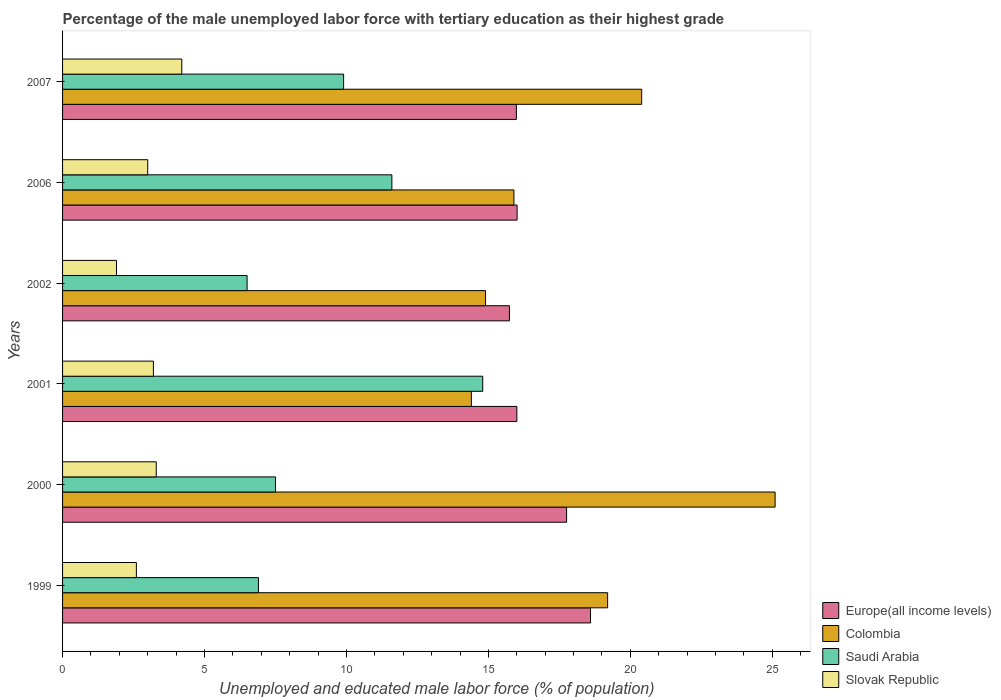How many different coloured bars are there?
Your answer should be compact. 4. How many groups of bars are there?
Offer a terse response. 6. How many bars are there on the 4th tick from the bottom?
Provide a short and direct response. 4. What is the label of the 6th group of bars from the top?
Offer a terse response. 1999. What is the percentage of the unemployed male labor force with tertiary education in Colombia in 2007?
Provide a succinct answer. 20.4. Across all years, what is the maximum percentage of the unemployed male labor force with tertiary education in Saudi Arabia?
Provide a short and direct response. 14.8. Across all years, what is the minimum percentage of the unemployed male labor force with tertiary education in Saudi Arabia?
Provide a short and direct response. 6.5. In which year was the percentage of the unemployed male labor force with tertiary education in Slovak Republic maximum?
Provide a succinct answer. 2007. What is the total percentage of the unemployed male labor force with tertiary education in Slovak Republic in the graph?
Provide a succinct answer. 18.2. What is the difference between the percentage of the unemployed male labor force with tertiary education in Colombia in 2006 and the percentage of the unemployed male labor force with tertiary education in Europe(all income levels) in 2007?
Ensure brevity in your answer.  -0.09. What is the average percentage of the unemployed male labor force with tertiary education in Saudi Arabia per year?
Provide a short and direct response. 9.53. In the year 2000, what is the difference between the percentage of the unemployed male labor force with tertiary education in Slovak Republic and percentage of the unemployed male labor force with tertiary education in Colombia?
Provide a succinct answer. -21.8. In how many years, is the percentage of the unemployed male labor force with tertiary education in Colombia greater than 3 %?
Your response must be concise. 6. What is the ratio of the percentage of the unemployed male labor force with tertiary education in Saudi Arabia in 2001 to that in 2006?
Keep it short and to the point. 1.28. Is the percentage of the unemployed male labor force with tertiary education in Slovak Republic in 2001 less than that in 2002?
Ensure brevity in your answer.  No. Is the difference between the percentage of the unemployed male labor force with tertiary education in Slovak Republic in 1999 and 2007 greater than the difference between the percentage of the unemployed male labor force with tertiary education in Colombia in 1999 and 2007?
Make the answer very short. No. What is the difference between the highest and the second highest percentage of the unemployed male labor force with tertiary education in Europe(all income levels)?
Provide a short and direct response. 0.84. What is the difference between the highest and the lowest percentage of the unemployed male labor force with tertiary education in Europe(all income levels)?
Offer a terse response. 2.86. Is it the case that in every year, the sum of the percentage of the unemployed male labor force with tertiary education in Saudi Arabia and percentage of the unemployed male labor force with tertiary education in Europe(all income levels) is greater than the sum of percentage of the unemployed male labor force with tertiary education in Colombia and percentage of the unemployed male labor force with tertiary education in Slovak Republic?
Your response must be concise. No. What does the 3rd bar from the bottom in 2006 represents?
Offer a terse response. Saudi Arabia. How many years are there in the graph?
Provide a short and direct response. 6. Are the values on the major ticks of X-axis written in scientific E-notation?
Your answer should be very brief. No. Does the graph contain any zero values?
Give a very brief answer. No. Where does the legend appear in the graph?
Keep it short and to the point. Bottom right. How many legend labels are there?
Give a very brief answer. 4. What is the title of the graph?
Your answer should be very brief. Percentage of the male unemployed labor force with tertiary education as their highest grade. What is the label or title of the X-axis?
Your answer should be very brief. Unemployed and educated male labor force (% of population). What is the Unemployed and educated male labor force (% of population) of Europe(all income levels) in 1999?
Provide a succinct answer. 18.6. What is the Unemployed and educated male labor force (% of population) in Colombia in 1999?
Your response must be concise. 19.2. What is the Unemployed and educated male labor force (% of population) of Saudi Arabia in 1999?
Your response must be concise. 6.9. What is the Unemployed and educated male labor force (% of population) in Slovak Republic in 1999?
Give a very brief answer. 2.6. What is the Unemployed and educated male labor force (% of population) of Europe(all income levels) in 2000?
Offer a terse response. 17.75. What is the Unemployed and educated male labor force (% of population) in Colombia in 2000?
Your response must be concise. 25.1. What is the Unemployed and educated male labor force (% of population) in Slovak Republic in 2000?
Keep it short and to the point. 3.3. What is the Unemployed and educated male labor force (% of population) of Europe(all income levels) in 2001?
Provide a succinct answer. 16. What is the Unemployed and educated male labor force (% of population) of Colombia in 2001?
Make the answer very short. 14.4. What is the Unemployed and educated male labor force (% of population) in Saudi Arabia in 2001?
Your answer should be very brief. 14.8. What is the Unemployed and educated male labor force (% of population) of Slovak Republic in 2001?
Give a very brief answer. 3.2. What is the Unemployed and educated male labor force (% of population) of Europe(all income levels) in 2002?
Give a very brief answer. 15.74. What is the Unemployed and educated male labor force (% of population) of Colombia in 2002?
Offer a terse response. 14.9. What is the Unemployed and educated male labor force (% of population) of Saudi Arabia in 2002?
Keep it short and to the point. 6.5. What is the Unemployed and educated male labor force (% of population) in Slovak Republic in 2002?
Provide a short and direct response. 1.9. What is the Unemployed and educated male labor force (% of population) of Europe(all income levels) in 2006?
Keep it short and to the point. 16.01. What is the Unemployed and educated male labor force (% of population) in Colombia in 2006?
Keep it short and to the point. 15.9. What is the Unemployed and educated male labor force (% of population) of Saudi Arabia in 2006?
Your answer should be compact. 11.6. What is the Unemployed and educated male labor force (% of population) in Europe(all income levels) in 2007?
Make the answer very short. 15.99. What is the Unemployed and educated male labor force (% of population) of Colombia in 2007?
Provide a short and direct response. 20.4. What is the Unemployed and educated male labor force (% of population) of Saudi Arabia in 2007?
Offer a very short reply. 9.9. What is the Unemployed and educated male labor force (% of population) of Slovak Republic in 2007?
Keep it short and to the point. 4.2. Across all years, what is the maximum Unemployed and educated male labor force (% of population) of Europe(all income levels)?
Ensure brevity in your answer.  18.6. Across all years, what is the maximum Unemployed and educated male labor force (% of population) of Colombia?
Provide a short and direct response. 25.1. Across all years, what is the maximum Unemployed and educated male labor force (% of population) of Saudi Arabia?
Offer a terse response. 14.8. Across all years, what is the maximum Unemployed and educated male labor force (% of population) in Slovak Republic?
Make the answer very short. 4.2. Across all years, what is the minimum Unemployed and educated male labor force (% of population) of Europe(all income levels)?
Ensure brevity in your answer.  15.74. Across all years, what is the minimum Unemployed and educated male labor force (% of population) of Colombia?
Offer a very short reply. 14.4. Across all years, what is the minimum Unemployed and educated male labor force (% of population) of Saudi Arabia?
Provide a short and direct response. 6.5. Across all years, what is the minimum Unemployed and educated male labor force (% of population) of Slovak Republic?
Make the answer very short. 1.9. What is the total Unemployed and educated male labor force (% of population) of Europe(all income levels) in the graph?
Ensure brevity in your answer.  100.09. What is the total Unemployed and educated male labor force (% of population) in Colombia in the graph?
Provide a short and direct response. 109.9. What is the total Unemployed and educated male labor force (% of population) of Saudi Arabia in the graph?
Provide a succinct answer. 57.2. What is the difference between the Unemployed and educated male labor force (% of population) in Europe(all income levels) in 1999 and that in 2000?
Offer a terse response. 0.84. What is the difference between the Unemployed and educated male labor force (% of population) of Colombia in 1999 and that in 2000?
Make the answer very short. -5.9. What is the difference between the Unemployed and educated male labor force (% of population) of Europe(all income levels) in 1999 and that in 2001?
Offer a terse response. 2.59. What is the difference between the Unemployed and educated male labor force (% of population) of Saudi Arabia in 1999 and that in 2001?
Keep it short and to the point. -7.9. What is the difference between the Unemployed and educated male labor force (% of population) in Europe(all income levels) in 1999 and that in 2002?
Your answer should be very brief. 2.86. What is the difference between the Unemployed and educated male labor force (% of population) of Slovak Republic in 1999 and that in 2002?
Provide a succinct answer. 0.7. What is the difference between the Unemployed and educated male labor force (% of population) of Europe(all income levels) in 1999 and that in 2006?
Give a very brief answer. 2.59. What is the difference between the Unemployed and educated male labor force (% of population) of Saudi Arabia in 1999 and that in 2006?
Your answer should be very brief. -4.7. What is the difference between the Unemployed and educated male labor force (% of population) in Slovak Republic in 1999 and that in 2006?
Ensure brevity in your answer.  -0.4. What is the difference between the Unemployed and educated male labor force (% of population) of Europe(all income levels) in 1999 and that in 2007?
Provide a succinct answer. 2.61. What is the difference between the Unemployed and educated male labor force (% of population) of Colombia in 1999 and that in 2007?
Provide a short and direct response. -1.2. What is the difference between the Unemployed and educated male labor force (% of population) of Saudi Arabia in 1999 and that in 2007?
Offer a very short reply. -3. What is the difference between the Unemployed and educated male labor force (% of population) in Europe(all income levels) in 2000 and that in 2001?
Keep it short and to the point. 1.75. What is the difference between the Unemployed and educated male labor force (% of population) in Colombia in 2000 and that in 2001?
Provide a short and direct response. 10.7. What is the difference between the Unemployed and educated male labor force (% of population) in Slovak Republic in 2000 and that in 2001?
Ensure brevity in your answer.  0.1. What is the difference between the Unemployed and educated male labor force (% of population) in Europe(all income levels) in 2000 and that in 2002?
Keep it short and to the point. 2.01. What is the difference between the Unemployed and educated male labor force (% of population) in Colombia in 2000 and that in 2002?
Ensure brevity in your answer.  10.2. What is the difference between the Unemployed and educated male labor force (% of population) in Europe(all income levels) in 2000 and that in 2006?
Offer a terse response. 1.74. What is the difference between the Unemployed and educated male labor force (% of population) of Colombia in 2000 and that in 2006?
Offer a terse response. 9.2. What is the difference between the Unemployed and educated male labor force (% of population) in Europe(all income levels) in 2000 and that in 2007?
Keep it short and to the point. 1.77. What is the difference between the Unemployed and educated male labor force (% of population) in Colombia in 2000 and that in 2007?
Offer a terse response. 4.7. What is the difference between the Unemployed and educated male labor force (% of population) in Europe(all income levels) in 2001 and that in 2002?
Your answer should be compact. 0.26. What is the difference between the Unemployed and educated male labor force (% of population) of Colombia in 2001 and that in 2002?
Your answer should be very brief. -0.5. What is the difference between the Unemployed and educated male labor force (% of population) of Europe(all income levels) in 2001 and that in 2006?
Your response must be concise. -0.01. What is the difference between the Unemployed and educated male labor force (% of population) in Saudi Arabia in 2001 and that in 2006?
Give a very brief answer. 3.2. What is the difference between the Unemployed and educated male labor force (% of population) of Europe(all income levels) in 2001 and that in 2007?
Your response must be concise. 0.02. What is the difference between the Unemployed and educated male labor force (% of population) in Europe(all income levels) in 2002 and that in 2006?
Provide a short and direct response. -0.27. What is the difference between the Unemployed and educated male labor force (% of population) of Colombia in 2002 and that in 2006?
Keep it short and to the point. -1. What is the difference between the Unemployed and educated male labor force (% of population) of Saudi Arabia in 2002 and that in 2006?
Your response must be concise. -5.1. What is the difference between the Unemployed and educated male labor force (% of population) of Europe(all income levels) in 2002 and that in 2007?
Make the answer very short. -0.25. What is the difference between the Unemployed and educated male labor force (% of population) in Saudi Arabia in 2002 and that in 2007?
Keep it short and to the point. -3.4. What is the difference between the Unemployed and educated male labor force (% of population) of Europe(all income levels) in 2006 and that in 2007?
Offer a terse response. 0.02. What is the difference between the Unemployed and educated male labor force (% of population) in Europe(all income levels) in 1999 and the Unemployed and educated male labor force (% of population) in Colombia in 2000?
Offer a terse response. -6.5. What is the difference between the Unemployed and educated male labor force (% of population) of Europe(all income levels) in 1999 and the Unemployed and educated male labor force (% of population) of Saudi Arabia in 2000?
Offer a terse response. 11.1. What is the difference between the Unemployed and educated male labor force (% of population) in Europe(all income levels) in 1999 and the Unemployed and educated male labor force (% of population) in Slovak Republic in 2000?
Offer a terse response. 15.3. What is the difference between the Unemployed and educated male labor force (% of population) of Colombia in 1999 and the Unemployed and educated male labor force (% of population) of Slovak Republic in 2000?
Provide a succinct answer. 15.9. What is the difference between the Unemployed and educated male labor force (% of population) in Europe(all income levels) in 1999 and the Unemployed and educated male labor force (% of population) in Colombia in 2001?
Keep it short and to the point. 4.2. What is the difference between the Unemployed and educated male labor force (% of population) in Europe(all income levels) in 1999 and the Unemployed and educated male labor force (% of population) in Saudi Arabia in 2001?
Keep it short and to the point. 3.8. What is the difference between the Unemployed and educated male labor force (% of population) in Europe(all income levels) in 1999 and the Unemployed and educated male labor force (% of population) in Slovak Republic in 2001?
Your answer should be compact. 15.4. What is the difference between the Unemployed and educated male labor force (% of population) of Colombia in 1999 and the Unemployed and educated male labor force (% of population) of Saudi Arabia in 2001?
Keep it short and to the point. 4.4. What is the difference between the Unemployed and educated male labor force (% of population) in Europe(all income levels) in 1999 and the Unemployed and educated male labor force (% of population) in Colombia in 2002?
Keep it short and to the point. 3.7. What is the difference between the Unemployed and educated male labor force (% of population) in Europe(all income levels) in 1999 and the Unemployed and educated male labor force (% of population) in Saudi Arabia in 2002?
Make the answer very short. 12.1. What is the difference between the Unemployed and educated male labor force (% of population) in Europe(all income levels) in 1999 and the Unemployed and educated male labor force (% of population) in Slovak Republic in 2002?
Offer a terse response. 16.7. What is the difference between the Unemployed and educated male labor force (% of population) in Colombia in 1999 and the Unemployed and educated male labor force (% of population) in Saudi Arabia in 2002?
Offer a terse response. 12.7. What is the difference between the Unemployed and educated male labor force (% of population) in Colombia in 1999 and the Unemployed and educated male labor force (% of population) in Slovak Republic in 2002?
Ensure brevity in your answer.  17.3. What is the difference between the Unemployed and educated male labor force (% of population) in Europe(all income levels) in 1999 and the Unemployed and educated male labor force (% of population) in Colombia in 2006?
Make the answer very short. 2.7. What is the difference between the Unemployed and educated male labor force (% of population) in Europe(all income levels) in 1999 and the Unemployed and educated male labor force (% of population) in Saudi Arabia in 2006?
Your answer should be compact. 7. What is the difference between the Unemployed and educated male labor force (% of population) of Europe(all income levels) in 1999 and the Unemployed and educated male labor force (% of population) of Slovak Republic in 2006?
Your answer should be very brief. 15.6. What is the difference between the Unemployed and educated male labor force (% of population) in Colombia in 1999 and the Unemployed and educated male labor force (% of population) in Slovak Republic in 2006?
Offer a very short reply. 16.2. What is the difference between the Unemployed and educated male labor force (% of population) in Europe(all income levels) in 1999 and the Unemployed and educated male labor force (% of population) in Colombia in 2007?
Your answer should be very brief. -1.8. What is the difference between the Unemployed and educated male labor force (% of population) of Europe(all income levels) in 1999 and the Unemployed and educated male labor force (% of population) of Saudi Arabia in 2007?
Provide a short and direct response. 8.7. What is the difference between the Unemployed and educated male labor force (% of population) in Europe(all income levels) in 1999 and the Unemployed and educated male labor force (% of population) in Slovak Republic in 2007?
Ensure brevity in your answer.  14.4. What is the difference between the Unemployed and educated male labor force (% of population) in Colombia in 1999 and the Unemployed and educated male labor force (% of population) in Saudi Arabia in 2007?
Offer a very short reply. 9.3. What is the difference between the Unemployed and educated male labor force (% of population) of Europe(all income levels) in 2000 and the Unemployed and educated male labor force (% of population) of Colombia in 2001?
Your response must be concise. 3.35. What is the difference between the Unemployed and educated male labor force (% of population) in Europe(all income levels) in 2000 and the Unemployed and educated male labor force (% of population) in Saudi Arabia in 2001?
Your response must be concise. 2.95. What is the difference between the Unemployed and educated male labor force (% of population) in Europe(all income levels) in 2000 and the Unemployed and educated male labor force (% of population) in Slovak Republic in 2001?
Provide a short and direct response. 14.55. What is the difference between the Unemployed and educated male labor force (% of population) of Colombia in 2000 and the Unemployed and educated male labor force (% of population) of Slovak Republic in 2001?
Keep it short and to the point. 21.9. What is the difference between the Unemployed and educated male labor force (% of population) in Saudi Arabia in 2000 and the Unemployed and educated male labor force (% of population) in Slovak Republic in 2001?
Make the answer very short. 4.3. What is the difference between the Unemployed and educated male labor force (% of population) of Europe(all income levels) in 2000 and the Unemployed and educated male labor force (% of population) of Colombia in 2002?
Give a very brief answer. 2.85. What is the difference between the Unemployed and educated male labor force (% of population) in Europe(all income levels) in 2000 and the Unemployed and educated male labor force (% of population) in Saudi Arabia in 2002?
Provide a short and direct response. 11.25. What is the difference between the Unemployed and educated male labor force (% of population) of Europe(all income levels) in 2000 and the Unemployed and educated male labor force (% of population) of Slovak Republic in 2002?
Your answer should be very brief. 15.85. What is the difference between the Unemployed and educated male labor force (% of population) of Colombia in 2000 and the Unemployed and educated male labor force (% of population) of Slovak Republic in 2002?
Ensure brevity in your answer.  23.2. What is the difference between the Unemployed and educated male labor force (% of population) in Saudi Arabia in 2000 and the Unemployed and educated male labor force (% of population) in Slovak Republic in 2002?
Give a very brief answer. 5.6. What is the difference between the Unemployed and educated male labor force (% of population) of Europe(all income levels) in 2000 and the Unemployed and educated male labor force (% of population) of Colombia in 2006?
Give a very brief answer. 1.85. What is the difference between the Unemployed and educated male labor force (% of population) in Europe(all income levels) in 2000 and the Unemployed and educated male labor force (% of population) in Saudi Arabia in 2006?
Provide a succinct answer. 6.15. What is the difference between the Unemployed and educated male labor force (% of population) of Europe(all income levels) in 2000 and the Unemployed and educated male labor force (% of population) of Slovak Republic in 2006?
Keep it short and to the point. 14.75. What is the difference between the Unemployed and educated male labor force (% of population) in Colombia in 2000 and the Unemployed and educated male labor force (% of population) in Slovak Republic in 2006?
Offer a very short reply. 22.1. What is the difference between the Unemployed and educated male labor force (% of population) of Saudi Arabia in 2000 and the Unemployed and educated male labor force (% of population) of Slovak Republic in 2006?
Your answer should be compact. 4.5. What is the difference between the Unemployed and educated male labor force (% of population) in Europe(all income levels) in 2000 and the Unemployed and educated male labor force (% of population) in Colombia in 2007?
Offer a very short reply. -2.65. What is the difference between the Unemployed and educated male labor force (% of population) of Europe(all income levels) in 2000 and the Unemployed and educated male labor force (% of population) of Saudi Arabia in 2007?
Offer a terse response. 7.85. What is the difference between the Unemployed and educated male labor force (% of population) in Europe(all income levels) in 2000 and the Unemployed and educated male labor force (% of population) in Slovak Republic in 2007?
Keep it short and to the point. 13.55. What is the difference between the Unemployed and educated male labor force (% of population) in Colombia in 2000 and the Unemployed and educated male labor force (% of population) in Slovak Republic in 2007?
Ensure brevity in your answer.  20.9. What is the difference between the Unemployed and educated male labor force (% of population) in Europe(all income levels) in 2001 and the Unemployed and educated male labor force (% of population) in Colombia in 2002?
Make the answer very short. 1.1. What is the difference between the Unemployed and educated male labor force (% of population) of Europe(all income levels) in 2001 and the Unemployed and educated male labor force (% of population) of Saudi Arabia in 2002?
Your answer should be compact. 9.5. What is the difference between the Unemployed and educated male labor force (% of population) in Europe(all income levels) in 2001 and the Unemployed and educated male labor force (% of population) in Slovak Republic in 2002?
Provide a succinct answer. 14.1. What is the difference between the Unemployed and educated male labor force (% of population) in Colombia in 2001 and the Unemployed and educated male labor force (% of population) in Slovak Republic in 2002?
Offer a very short reply. 12.5. What is the difference between the Unemployed and educated male labor force (% of population) of Europe(all income levels) in 2001 and the Unemployed and educated male labor force (% of population) of Colombia in 2006?
Give a very brief answer. 0.1. What is the difference between the Unemployed and educated male labor force (% of population) of Europe(all income levels) in 2001 and the Unemployed and educated male labor force (% of population) of Saudi Arabia in 2006?
Offer a very short reply. 4.4. What is the difference between the Unemployed and educated male labor force (% of population) in Europe(all income levels) in 2001 and the Unemployed and educated male labor force (% of population) in Slovak Republic in 2006?
Ensure brevity in your answer.  13. What is the difference between the Unemployed and educated male labor force (% of population) in Colombia in 2001 and the Unemployed and educated male labor force (% of population) in Slovak Republic in 2006?
Offer a terse response. 11.4. What is the difference between the Unemployed and educated male labor force (% of population) of Saudi Arabia in 2001 and the Unemployed and educated male labor force (% of population) of Slovak Republic in 2006?
Ensure brevity in your answer.  11.8. What is the difference between the Unemployed and educated male labor force (% of population) in Europe(all income levels) in 2001 and the Unemployed and educated male labor force (% of population) in Colombia in 2007?
Your answer should be very brief. -4.4. What is the difference between the Unemployed and educated male labor force (% of population) in Europe(all income levels) in 2001 and the Unemployed and educated male labor force (% of population) in Saudi Arabia in 2007?
Provide a succinct answer. 6.1. What is the difference between the Unemployed and educated male labor force (% of population) of Europe(all income levels) in 2001 and the Unemployed and educated male labor force (% of population) of Slovak Republic in 2007?
Give a very brief answer. 11.8. What is the difference between the Unemployed and educated male labor force (% of population) in Europe(all income levels) in 2002 and the Unemployed and educated male labor force (% of population) in Colombia in 2006?
Provide a succinct answer. -0.16. What is the difference between the Unemployed and educated male labor force (% of population) in Europe(all income levels) in 2002 and the Unemployed and educated male labor force (% of population) in Saudi Arabia in 2006?
Make the answer very short. 4.14. What is the difference between the Unemployed and educated male labor force (% of population) in Europe(all income levels) in 2002 and the Unemployed and educated male labor force (% of population) in Slovak Republic in 2006?
Provide a short and direct response. 12.74. What is the difference between the Unemployed and educated male labor force (% of population) in Colombia in 2002 and the Unemployed and educated male labor force (% of population) in Saudi Arabia in 2006?
Provide a succinct answer. 3.3. What is the difference between the Unemployed and educated male labor force (% of population) in Colombia in 2002 and the Unemployed and educated male labor force (% of population) in Slovak Republic in 2006?
Ensure brevity in your answer.  11.9. What is the difference between the Unemployed and educated male labor force (% of population) of Saudi Arabia in 2002 and the Unemployed and educated male labor force (% of population) of Slovak Republic in 2006?
Provide a succinct answer. 3.5. What is the difference between the Unemployed and educated male labor force (% of population) in Europe(all income levels) in 2002 and the Unemployed and educated male labor force (% of population) in Colombia in 2007?
Your answer should be compact. -4.66. What is the difference between the Unemployed and educated male labor force (% of population) of Europe(all income levels) in 2002 and the Unemployed and educated male labor force (% of population) of Saudi Arabia in 2007?
Provide a short and direct response. 5.84. What is the difference between the Unemployed and educated male labor force (% of population) of Europe(all income levels) in 2002 and the Unemployed and educated male labor force (% of population) of Slovak Republic in 2007?
Give a very brief answer. 11.54. What is the difference between the Unemployed and educated male labor force (% of population) in Colombia in 2002 and the Unemployed and educated male labor force (% of population) in Saudi Arabia in 2007?
Offer a very short reply. 5. What is the difference between the Unemployed and educated male labor force (% of population) in Saudi Arabia in 2002 and the Unemployed and educated male labor force (% of population) in Slovak Republic in 2007?
Your answer should be compact. 2.3. What is the difference between the Unemployed and educated male labor force (% of population) of Europe(all income levels) in 2006 and the Unemployed and educated male labor force (% of population) of Colombia in 2007?
Ensure brevity in your answer.  -4.39. What is the difference between the Unemployed and educated male labor force (% of population) of Europe(all income levels) in 2006 and the Unemployed and educated male labor force (% of population) of Saudi Arabia in 2007?
Your response must be concise. 6.11. What is the difference between the Unemployed and educated male labor force (% of population) of Europe(all income levels) in 2006 and the Unemployed and educated male labor force (% of population) of Slovak Republic in 2007?
Your response must be concise. 11.81. What is the difference between the Unemployed and educated male labor force (% of population) in Colombia in 2006 and the Unemployed and educated male labor force (% of population) in Saudi Arabia in 2007?
Provide a short and direct response. 6. What is the difference between the Unemployed and educated male labor force (% of population) in Colombia in 2006 and the Unemployed and educated male labor force (% of population) in Slovak Republic in 2007?
Keep it short and to the point. 11.7. What is the difference between the Unemployed and educated male labor force (% of population) of Saudi Arabia in 2006 and the Unemployed and educated male labor force (% of population) of Slovak Republic in 2007?
Ensure brevity in your answer.  7.4. What is the average Unemployed and educated male labor force (% of population) of Europe(all income levels) per year?
Keep it short and to the point. 16.68. What is the average Unemployed and educated male labor force (% of population) in Colombia per year?
Your response must be concise. 18.32. What is the average Unemployed and educated male labor force (% of population) of Saudi Arabia per year?
Provide a succinct answer. 9.53. What is the average Unemployed and educated male labor force (% of population) in Slovak Republic per year?
Provide a succinct answer. 3.03. In the year 1999, what is the difference between the Unemployed and educated male labor force (% of population) in Europe(all income levels) and Unemployed and educated male labor force (% of population) in Colombia?
Your answer should be compact. -0.6. In the year 1999, what is the difference between the Unemployed and educated male labor force (% of population) of Europe(all income levels) and Unemployed and educated male labor force (% of population) of Saudi Arabia?
Give a very brief answer. 11.7. In the year 1999, what is the difference between the Unemployed and educated male labor force (% of population) of Europe(all income levels) and Unemployed and educated male labor force (% of population) of Slovak Republic?
Your answer should be compact. 16. In the year 1999, what is the difference between the Unemployed and educated male labor force (% of population) of Colombia and Unemployed and educated male labor force (% of population) of Saudi Arabia?
Give a very brief answer. 12.3. In the year 1999, what is the difference between the Unemployed and educated male labor force (% of population) in Colombia and Unemployed and educated male labor force (% of population) in Slovak Republic?
Give a very brief answer. 16.6. In the year 2000, what is the difference between the Unemployed and educated male labor force (% of population) of Europe(all income levels) and Unemployed and educated male labor force (% of population) of Colombia?
Provide a succinct answer. -7.35. In the year 2000, what is the difference between the Unemployed and educated male labor force (% of population) of Europe(all income levels) and Unemployed and educated male labor force (% of population) of Saudi Arabia?
Provide a succinct answer. 10.25. In the year 2000, what is the difference between the Unemployed and educated male labor force (% of population) of Europe(all income levels) and Unemployed and educated male labor force (% of population) of Slovak Republic?
Provide a short and direct response. 14.45. In the year 2000, what is the difference between the Unemployed and educated male labor force (% of population) in Colombia and Unemployed and educated male labor force (% of population) in Saudi Arabia?
Your response must be concise. 17.6. In the year 2000, what is the difference between the Unemployed and educated male labor force (% of population) of Colombia and Unemployed and educated male labor force (% of population) of Slovak Republic?
Give a very brief answer. 21.8. In the year 2001, what is the difference between the Unemployed and educated male labor force (% of population) in Europe(all income levels) and Unemployed and educated male labor force (% of population) in Colombia?
Your answer should be compact. 1.6. In the year 2001, what is the difference between the Unemployed and educated male labor force (% of population) in Europe(all income levels) and Unemployed and educated male labor force (% of population) in Saudi Arabia?
Provide a short and direct response. 1.2. In the year 2001, what is the difference between the Unemployed and educated male labor force (% of population) in Europe(all income levels) and Unemployed and educated male labor force (% of population) in Slovak Republic?
Your answer should be very brief. 12.8. In the year 2001, what is the difference between the Unemployed and educated male labor force (% of population) of Colombia and Unemployed and educated male labor force (% of population) of Slovak Republic?
Keep it short and to the point. 11.2. In the year 2001, what is the difference between the Unemployed and educated male labor force (% of population) in Saudi Arabia and Unemployed and educated male labor force (% of population) in Slovak Republic?
Your answer should be very brief. 11.6. In the year 2002, what is the difference between the Unemployed and educated male labor force (% of population) of Europe(all income levels) and Unemployed and educated male labor force (% of population) of Colombia?
Your answer should be very brief. 0.84. In the year 2002, what is the difference between the Unemployed and educated male labor force (% of population) in Europe(all income levels) and Unemployed and educated male labor force (% of population) in Saudi Arabia?
Ensure brevity in your answer.  9.24. In the year 2002, what is the difference between the Unemployed and educated male labor force (% of population) of Europe(all income levels) and Unemployed and educated male labor force (% of population) of Slovak Republic?
Provide a succinct answer. 13.84. In the year 2002, what is the difference between the Unemployed and educated male labor force (% of population) in Colombia and Unemployed and educated male labor force (% of population) in Saudi Arabia?
Your answer should be compact. 8.4. In the year 2002, what is the difference between the Unemployed and educated male labor force (% of population) of Colombia and Unemployed and educated male labor force (% of population) of Slovak Republic?
Your answer should be compact. 13. In the year 2006, what is the difference between the Unemployed and educated male labor force (% of population) in Europe(all income levels) and Unemployed and educated male labor force (% of population) in Colombia?
Give a very brief answer. 0.11. In the year 2006, what is the difference between the Unemployed and educated male labor force (% of population) in Europe(all income levels) and Unemployed and educated male labor force (% of population) in Saudi Arabia?
Your answer should be very brief. 4.41. In the year 2006, what is the difference between the Unemployed and educated male labor force (% of population) of Europe(all income levels) and Unemployed and educated male labor force (% of population) of Slovak Republic?
Offer a terse response. 13.01. In the year 2006, what is the difference between the Unemployed and educated male labor force (% of population) in Colombia and Unemployed and educated male labor force (% of population) in Slovak Republic?
Make the answer very short. 12.9. In the year 2006, what is the difference between the Unemployed and educated male labor force (% of population) of Saudi Arabia and Unemployed and educated male labor force (% of population) of Slovak Republic?
Your answer should be compact. 8.6. In the year 2007, what is the difference between the Unemployed and educated male labor force (% of population) in Europe(all income levels) and Unemployed and educated male labor force (% of population) in Colombia?
Make the answer very short. -4.41. In the year 2007, what is the difference between the Unemployed and educated male labor force (% of population) of Europe(all income levels) and Unemployed and educated male labor force (% of population) of Saudi Arabia?
Your answer should be compact. 6.09. In the year 2007, what is the difference between the Unemployed and educated male labor force (% of population) in Europe(all income levels) and Unemployed and educated male labor force (% of population) in Slovak Republic?
Make the answer very short. 11.79. In the year 2007, what is the difference between the Unemployed and educated male labor force (% of population) in Colombia and Unemployed and educated male labor force (% of population) in Slovak Republic?
Your answer should be compact. 16.2. In the year 2007, what is the difference between the Unemployed and educated male labor force (% of population) of Saudi Arabia and Unemployed and educated male labor force (% of population) of Slovak Republic?
Make the answer very short. 5.7. What is the ratio of the Unemployed and educated male labor force (% of population) in Europe(all income levels) in 1999 to that in 2000?
Your response must be concise. 1.05. What is the ratio of the Unemployed and educated male labor force (% of population) in Colombia in 1999 to that in 2000?
Keep it short and to the point. 0.76. What is the ratio of the Unemployed and educated male labor force (% of population) in Slovak Republic in 1999 to that in 2000?
Ensure brevity in your answer.  0.79. What is the ratio of the Unemployed and educated male labor force (% of population) in Europe(all income levels) in 1999 to that in 2001?
Your answer should be compact. 1.16. What is the ratio of the Unemployed and educated male labor force (% of population) in Saudi Arabia in 1999 to that in 2001?
Make the answer very short. 0.47. What is the ratio of the Unemployed and educated male labor force (% of population) of Slovak Republic in 1999 to that in 2001?
Make the answer very short. 0.81. What is the ratio of the Unemployed and educated male labor force (% of population) in Europe(all income levels) in 1999 to that in 2002?
Your response must be concise. 1.18. What is the ratio of the Unemployed and educated male labor force (% of population) in Colombia in 1999 to that in 2002?
Ensure brevity in your answer.  1.29. What is the ratio of the Unemployed and educated male labor force (% of population) of Saudi Arabia in 1999 to that in 2002?
Your answer should be compact. 1.06. What is the ratio of the Unemployed and educated male labor force (% of population) in Slovak Republic in 1999 to that in 2002?
Provide a short and direct response. 1.37. What is the ratio of the Unemployed and educated male labor force (% of population) in Europe(all income levels) in 1999 to that in 2006?
Provide a short and direct response. 1.16. What is the ratio of the Unemployed and educated male labor force (% of population) in Colombia in 1999 to that in 2006?
Make the answer very short. 1.21. What is the ratio of the Unemployed and educated male labor force (% of population) in Saudi Arabia in 1999 to that in 2006?
Keep it short and to the point. 0.59. What is the ratio of the Unemployed and educated male labor force (% of population) of Slovak Republic in 1999 to that in 2006?
Your answer should be compact. 0.87. What is the ratio of the Unemployed and educated male labor force (% of population) in Europe(all income levels) in 1999 to that in 2007?
Your answer should be compact. 1.16. What is the ratio of the Unemployed and educated male labor force (% of population) in Colombia in 1999 to that in 2007?
Keep it short and to the point. 0.94. What is the ratio of the Unemployed and educated male labor force (% of population) of Saudi Arabia in 1999 to that in 2007?
Offer a very short reply. 0.7. What is the ratio of the Unemployed and educated male labor force (% of population) in Slovak Republic in 1999 to that in 2007?
Give a very brief answer. 0.62. What is the ratio of the Unemployed and educated male labor force (% of population) of Europe(all income levels) in 2000 to that in 2001?
Keep it short and to the point. 1.11. What is the ratio of the Unemployed and educated male labor force (% of population) in Colombia in 2000 to that in 2001?
Offer a very short reply. 1.74. What is the ratio of the Unemployed and educated male labor force (% of population) in Saudi Arabia in 2000 to that in 2001?
Provide a short and direct response. 0.51. What is the ratio of the Unemployed and educated male labor force (% of population) in Slovak Republic in 2000 to that in 2001?
Keep it short and to the point. 1.03. What is the ratio of the Unemployed and educated male labor force (% of population) of Europe(all income levels) in 2000 to that in 2002?
Your answer should be compact. 1.13. What is the ratio of the Unemployed and educated male labor force (% of population) of Colombia in 2000 to that in 2002?
Give a very brief answer. 1.68. What is the ratio of the Unemployed and educated male labor force (% of population) of Saudi Arabia in 2000 to that in 2002?
Ensure brevity in your answer.  1.15. What is the ratio of the Unemployed and educated male labor force (% of population) of Slovak Republic in 2000 to that in 2002?
Give a very brief answer. 1.74. What is the ratio of the Unemployed and educated male labor force (% of population) of Europe(all income levels) in 2000 to that in 2006?
Keep it short and to the point. 1.11. What is the ratio of the Unemployed and educated male labor force (% of population) of Colombia in 2000 to that in 2006?
Ensure brevity in your answer.  1.58. What is the ratio of the Unemployed and educated male labor force (% of population) of Saudi Arabia in 2000 to that in 2006?
Offer a very short reply. 0.65. What is the ratio of the Unemployed and educated male labor force (% of population) in Slovak Republic in 2000 to that in 2006?
Offer a terse response. 1.1. What is the ratio of the Unemployed and educated male labor force (% of population) of Europe(all income levels) in 2000 to that in 2007?
Your answer should be compact. 1.11. What is the ratio of the Unemployed and educated male labor force (% of population) in Colombia in 2000 to that in 2007?
Your answer should be compact. 1.23. What is the ratio of the Unemployed and educated male labor force (% of population) of Saudi Arabia in 2000 to that in 2007?
Make the answer very short. 0.76. What is the ratio of the Unemployed and educated male labor force (% of population) in Slovak Republic in 2000 to that in 2007?
Your answer should be very brief. 0.79. What is the ratio of the Unemployed and educated male labor force (% of population) of Europe(all income levels) in 2001 to that in 2002?
Your answer should be very brief. 1.02. What is the ratio of the Unemployed and educated male labor force (% of population) in Colombia in 2001 to that in 2002?
Make the answer very short. 0.97. What is the ratio of the Unemployed and educated male labor force (% of population) in Saudi Arabia in 2001 to that in 2002?
Ensure brevity in your answer.  2.28. What is the ratio of the Unemployed and educated male labor force (% of population) in Slovak Republic in 2001 to that in 2002?
Provide a short and direct response. 1.68. What is the ratio of the Unemployed and educated male labor force (% of population) in Europe(all income levels) in 2001 to that in 2006?
Your answer should be compact. 1. What is the ratio of the Unemployed and educated male labor force (% of population) in Colombia in 2001 to that in 2006?
Your answer should be compact. 0.91. What is the ratio of the Unemployed and educated male labor force (% of population) of Saudi Arabia in 2001 to that in 2006?
Your answer should be compact. 1.28. What is the ratio of the Unemployed and educated male labor force (% of population) in Slovak Republic in 2001 to that in 2006?
Offer a very short reply. 1.07. What is the ratio of the Unemployed and educated male labor force (% of population) of Colombia in 2001 to that in 2007?
Make the answer very short. 0.71. What is the ratio of the Unemployed and educated male labor force (% of population) in Saudi Arabia in 2001 to that in 2007?
Keep it short and to the point. 1.49. What is the ratio of the Unemployed and educated male labor force (% of population) in Slovak Republic in 2001 to that in 2007?
Offer a terse response. 0.76. What is the ratio of the Unemployed and educated male labor force (% of population) in Europe(all income levels) in 2002 to that in 2006?
Provide a short and direct response. 0.98. What is the ratio of the Unemployed and educated male labor force (% of population) in Colombia in 2002 to that in 2006?
Ensure brevity in your answer.  0.94. What is the ratio of the Unemployed and educated male labor force (% of population) in Saudi Arabia in 2002 to that in 2006?
Your answer should be compact. 0.56. What is the ratio of the Unemployed and educated male labor force (% of population) of Slovak Republic in 2002 to that in 2006?
Keep it short and to the point. 0.63. What is the ratio of the Unemployed and educated male labor force (% of population) of Europe(all income levels) in 2002 to that in 2007?
Ensure brevity in your answer.  0.98. What is the ratio of the Unemployed and educated male labor force (% of population) of Colombia in 2002 to that in 2007?
Offer a terse response. 0.73. What is the ratio of the Unemployed and educated male labor force (% of population) in Saudi Arabia in 2002 to that in 2007?
Your answer should be compact. 0.66. What is the ratio of the Unemployed and educated male labor force (% of population) of Slovak Republic in 2002 to that in 2007?
Offer a very short reply. 0.45. What is the ratio of the Unemployed and educated male labor force (% of population) of Colombia in 2006 to that in 2007?
Provide a short and direct response. 0.78. What is the ratio of the Unemployed and educated male labor force (% of population) in Saudi Arabia in 2006 to that in 2007?
Keep it short and to the point. 1.17. What is the difference between the highest and the second highest Unemployed and educated male labor force (% of population) of Europe(all income levels)?
Give a very brief answer. 0.84. What is the difference between the highest and the second highest Unemployed and educated male labor force (% of population) in Colombia?
Your response must be concise. 4.7. What is the difference between the highest and the second highest Unemployed and educated male labor force (% of population) in Saudi Arabia?
Provide a short and direct response. 3.2. What is the difference between the highest and the second highest Unemployed and educated male labor force (% of population) of Slovak Republic?
Make the answer very short. 0.9. What is the difference between the highest and the lowest Unemployed and educated male labor force (% of population) of Europe(all income levels)?
Your answer should be very brief. 2.86. What is the difference between the highest and the lowest Unemployed and educated male labor force (% of population) in Colombia?
Your answer should be compact. 10.7. What is the difference between the highest and the lowest Unemployed and educated male labor force (% of population) in Slovak Republic?
Your response must be concise. 2.3. 